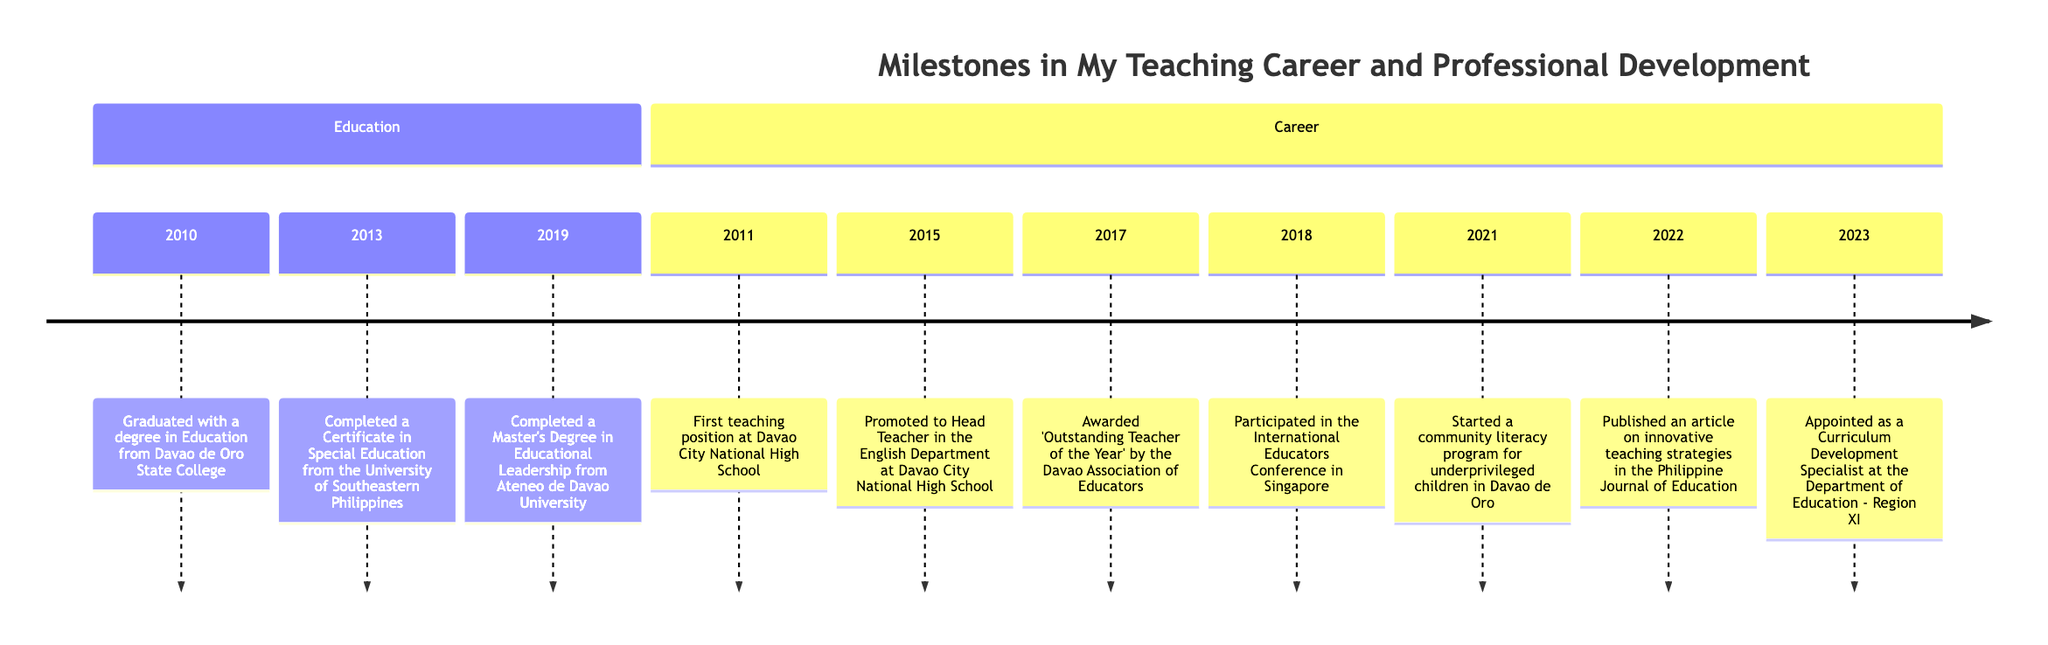What year did you graduate from Davao de Oro State College? The timeline shows that the milestone "Graduated with a degree in Education from Davao de Oro State College" is listed under the year 2010.
Answer: 2010 What milestone occurred first in your career? The first milestone listed in the Career section is "First teaching position at Davao City National High School," which is in the year 2011.
Answer: First teaching position at Davao City National High School How many years did it take to obtain a Master's Degree after graduating from college? The graduation year is 2010, and the Master's Degree was completed in 2019. The difference between 2019 and 2010 is 9 years.
Answer: 9 years What recognition did you receive in 2017? In the year 2017, the timeline states that the milestone is "Awarded 'Outstanding Teacher of the Year' by the Davao Association of Educators."
Answer: Outstanding Teacher of the Year Which year did you start the community literacy program? The timeline indicates that the community literacy program was started in 2021.
Answer: 2021 What is the last milestone listed on the timeline? The final milestone in the list is "Appointed as a Curriculum Development Specialist at the Department of Education - Region XI," which is dated 2023.
Answer: Appointed as a Curriculum Development Specialist at the Department of Education - Region XI How many milestones are related to education completion? The timeline shows three educational milestones: graduation in 2010, completing a Certificate in Special Education in 2013, and completing a Master's Degree in 2019. Therefore, there are three education-related milestones.
Answer: 3 What event did you participate in during 2018? In 2018, the timeline mentions the milestone "Participated in the International Educators Conference in Singapore."
Answer: Participated in the International Educators Conference in Singapore In which department were you promoted to Head Teacher? The milestone states that you were promoted to Head Teacher in the English Department, specifically stating that this occurred at Davao City National High School in 2015.
Answer: English Department 